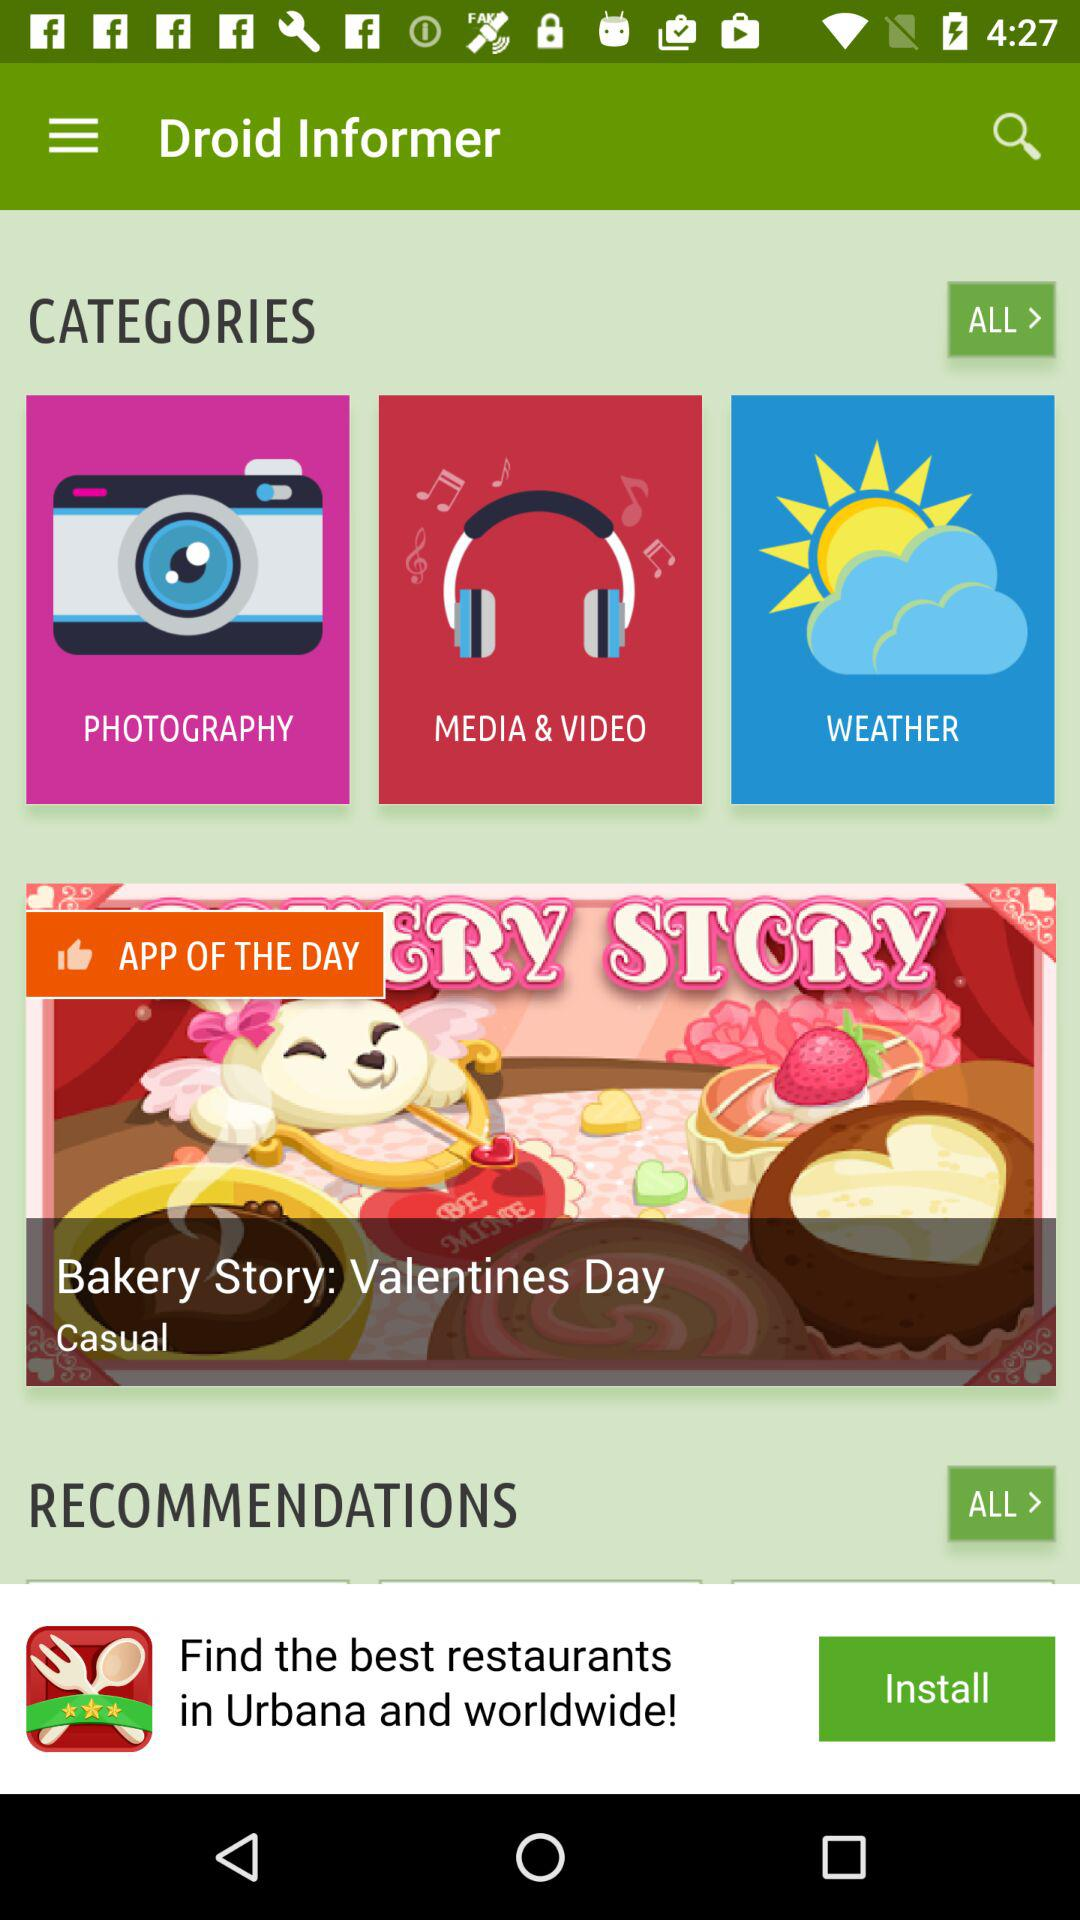What is the name of the application? The names of the applications are "Droid Informer" and "Bakery Story: Valentines Day". 